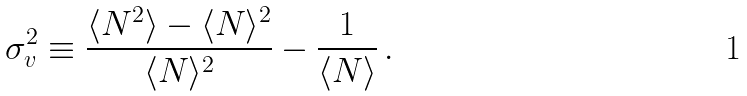Convert formula to latex. <formula><loc_0><loc_0><loc_500><loc_500>\sigma ^ { 2 } _ { v } \equiv \frac { \langle N ^ { 2 } \rangle - \langle N \rangle ^ { 2 } } { \langle N \rangle ^ { 2 } } - \frac { 1 } { \langle N \rangle } \, .</formula> 